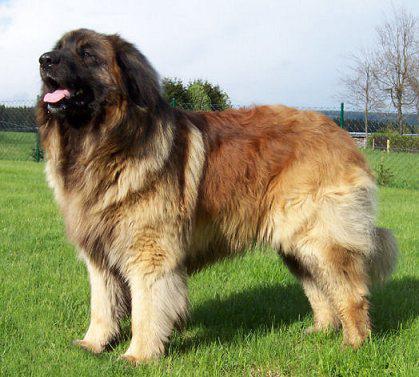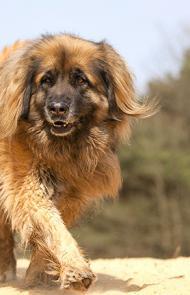The first image is the image on the left, the second image is the image on the right. For the images shown, is this caption "A person is standing by a large dog in one image." true? Answer yes or no. No. 